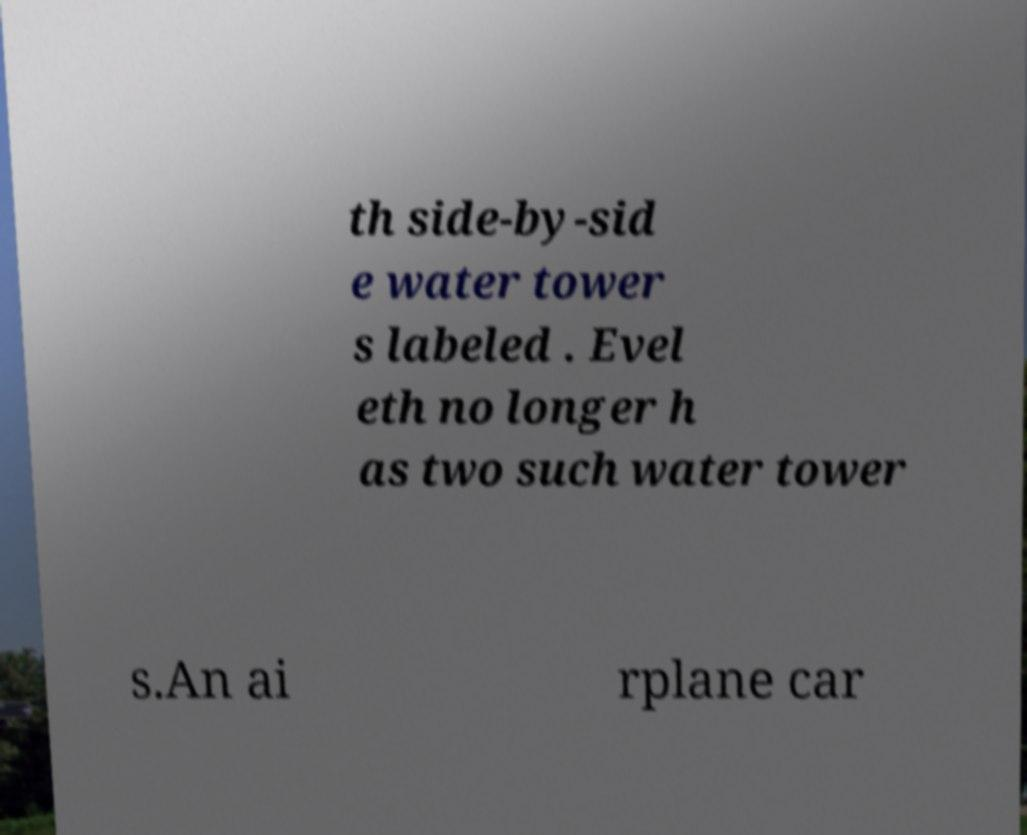Please read and relay the text visible in this image. What does it say? th side-by-sid e water tower s labeled . Evel eth no longer h as two such water tower s.An ai rplane car 